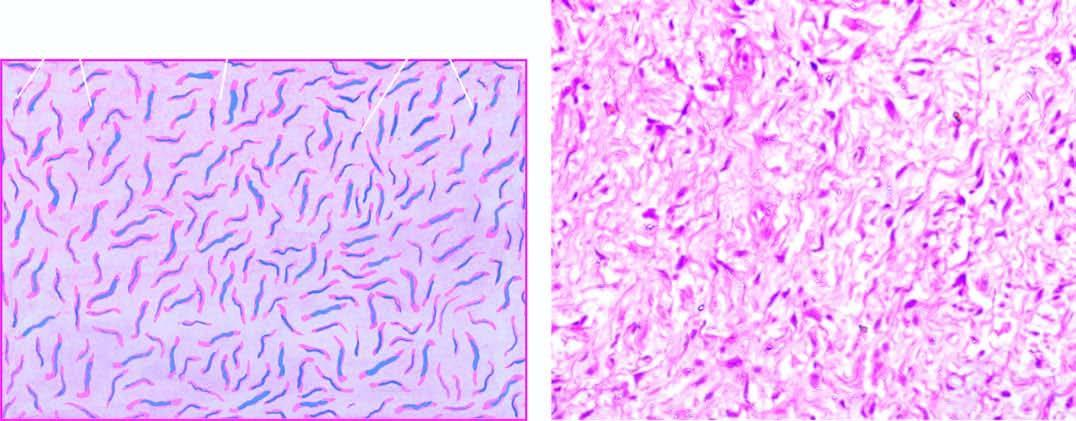what do the cells have?
Answer the question using a single word or phrase. Wavy nuclei 